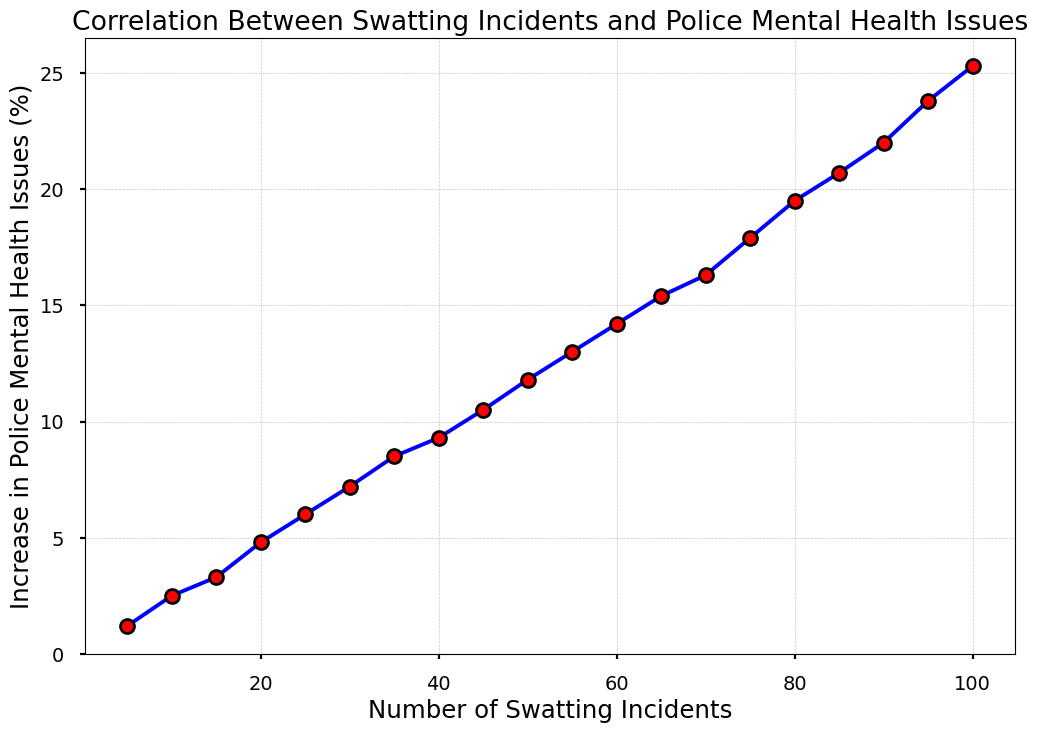What is the percentage increase in police mental health issues when the number of swatting incidents rises from 20 to 40? The figure shows that at 20 swatting incidents, the increase in police mental health issues is 4.8%. At 40 incidents, it is 9.3%. The percentage increase is thus 9.3% - 4.8% = 4.5%.
Answer: 4.5% Which has a higher increase in police mental health issues: 50 incidents or 30 incidents? According to the figure, at 50 incidents, the increase is 11.8%, while at 30 incidents, it is 7.2%. Therefore, 50 incidents result in a higher increase.
Answer: 50 incidents What is the average increase in police mental health issues for 10, 20, and 30 swatting incidents? The figure shows increases of 2.5% for 10 incidents, 4.8% for 20 incidents, and 7.2% for 30 incidents. The average is (2.5 + 4.8 + 7.2) / 3 = 14.5 / 3 = approximately 4.83%.
Answer: approximately 4.83% How does the increase in mental health issues at 60 incidents compare to the increase at 100 incidents? The figure shows an increase of 14.2% at 60 incidents and 25.3% at 100 incidents. Therefore, the increase at 100 incidents is significantly higher.
Answer: 100 incidents By how much does the increase in police mental health issues grow between 70 and 90 swatting incidents? The figure shows the increase at 70 incidents is 16.3% and at 90 incidents is 22.0%. The difference is 22.0% - 16.3% = 5.7%.
Answer: 5.7% What is the total increase in police mental health issues for 5, 15, and 35 swatting incidents? The figure shows the increases are 1.2% for 5 incidents, 3.3% for 15 incidents, and 8.5% for 35 incidents. The total increase is 1.2% + 3.3% + 8.5% = 13%.
Answer: 13% Which incident count shows a closer increase to 10% in police mental health issues: 45 incidents or 50 incidents? The figure shows an increase of 10.5% for 45 incidents and 11.8% for 50 incidents. Therefore, 45 incidents are closer to a 10% increase.
Answer: 45 incidents What is the trend of the correlation between the number of swatting incidents and police mental health issues? The figure illustrates a positive correlation; as the number of swatting incidents increases, the percentage of police mental health issues also increases.
Answer: Positive correlation 